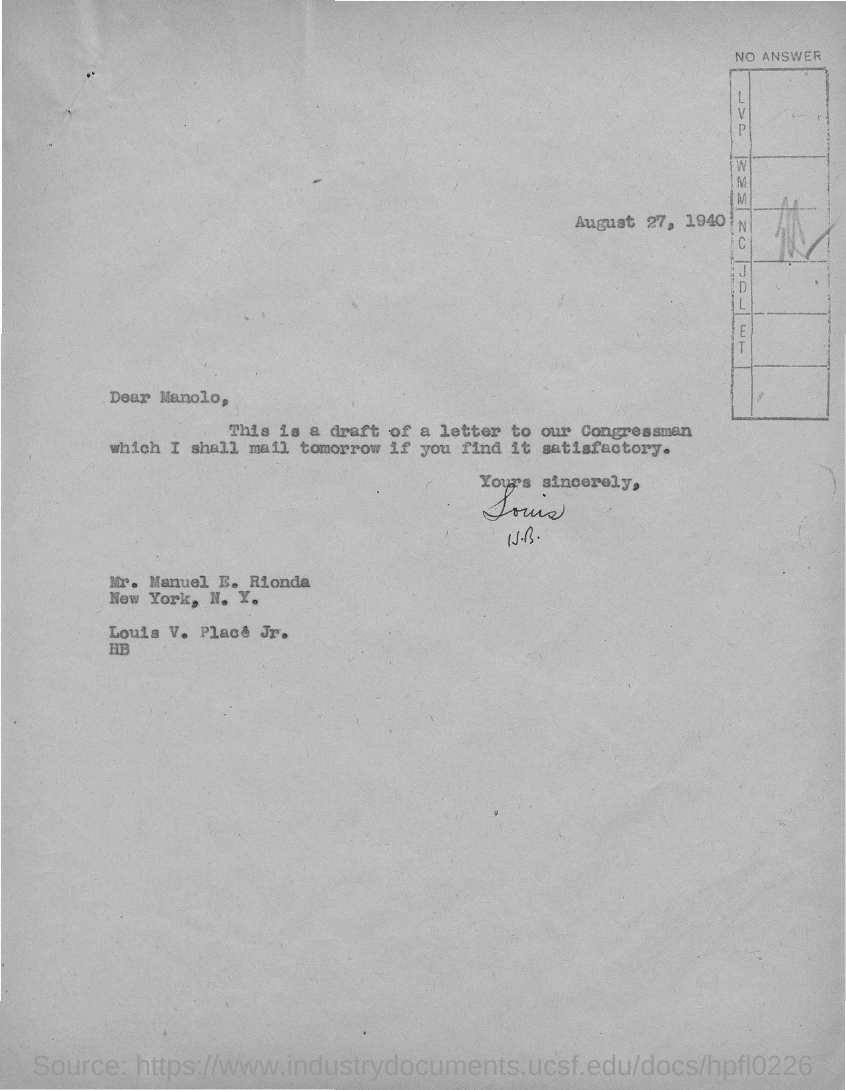Indicate a few pertinent items in this graphic. The document's date is August 27, 1940. The letter is from Louis V. Place Jr. The letter is addressed to Mr. Manuel E. Rionda. This is a draft of a letter to our Congressman, a document that will serve as a communication from one individual or group to an official representative, expressing their views and opinions on a particular matter, and seeking action or redress on their behalf. 